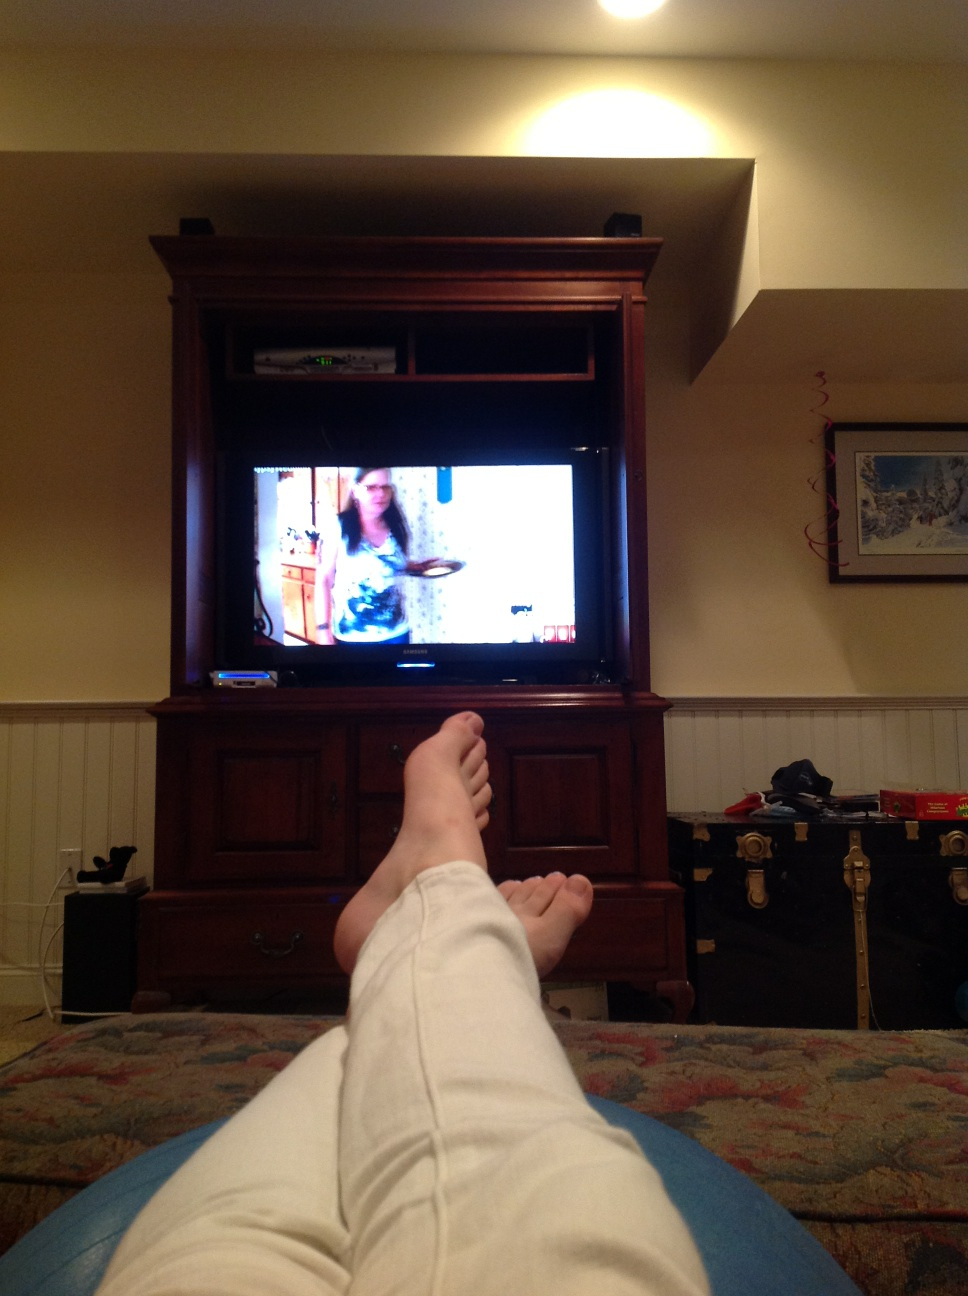How many toes does this person have? While I can't provide specific details about a real person, typically, a person has 10 toes. However, in the photo provided, I'm unable to count the individual toes due to the angle and resolution of the image. 